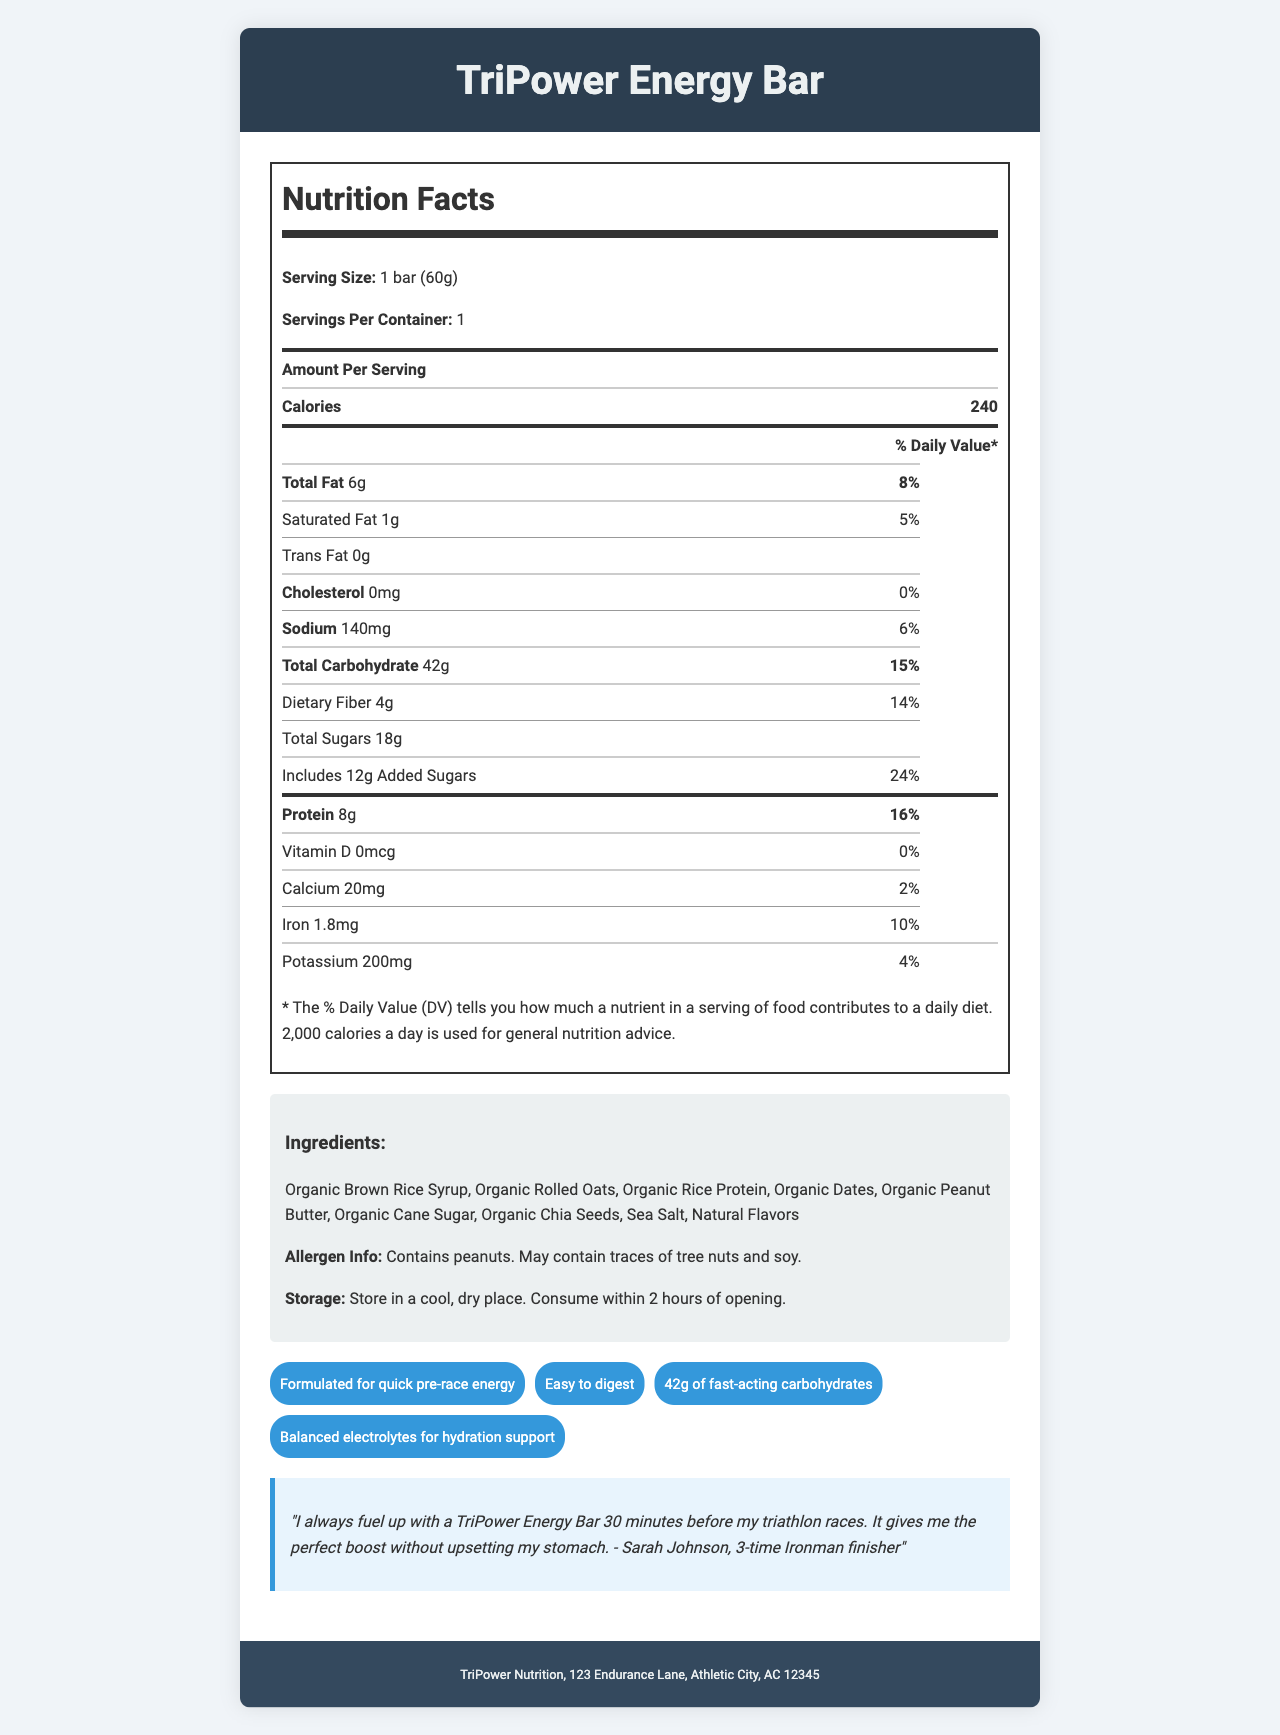what is the serving size of the TriPower Energy Bar? The document states that the serving size is 1 bar (60g).
Answer: 1 bar (60g) how many calories are there per serving? The document mentions that there are 240 calories per serving.
Answer: 240 what is the total carbohydrate content per serving? The document indicates that the total carbohydrate content per serving is 42g.
Answer: 42g how much dietary fiber does the TriPower Energy Bar have? The document lists the dietary fiber content as 4g per serving.
Answer: 4g what is the percentage of daily value for protein in this energy bar? The document specifies that the protein daily value percentage is 16%.
Answer: 16% which ingredient is listed first on the ingredients list? The first ingredient listed is Organic Brown Rice Syrup.
Answer: Organic Brown Rice Syrup how much added sugar does the TriPower Energy Bar contain? The document indicates that the energy bar contains 12g of added sugars.
Answer: 12g what company manufactures the TriPower Energy Bar? The manufacturer information in the document states that TriPower Nutrition produces the bar.
Answer: TriPower Nutrition does the TriPower Energy Bar contain any peanuts? The allergen info mentions that the product contains peanuts.
Answer: Yes which of the following is not listed as an ingredient? A. Organic Chia Seeds B. Organic Honey C. Organic Rolled Oats The document lists Organic Chia Seeds and Organic Rolled Oats, but not Organic Honey.
Answer: B. Organic Honey how much sodium is present in one serving of the energy bar? A. 120 mg B. 130 mg C. 140 mg D. 150 mg The nutrition facts indicate that each serving contains 140 mg of sodium.
Answer: C. 140 mg what is the daily value percentage for iron in the TriPower Energy Bar? A. 5% B. 10% C. 15% The nutrition facts show that the daily value percentage for iron is 10%.
Answer: B. 10% should the TriPower Energy Bar be stored in a cool, dry place? The storage instructions recommend keeping the bar in a cool, dry place.
Answer: Yes what is the main purpose of the TriPower Energy Bar according to the claim statements? The claim statements highlight that the bar is formulated for quick pre-race energy.
Answer: Quick pre-race energy which athlete endorses the TriPower Energy Bar in the testimonial? The document includes a testimonial from Sarah Johnson, a 3-time Ironman finisher.
Answer: Sarah Johnson what is the role of potassium in the TriPower Energy Bar? The document lists the amount of potassium and its daily value percentage but does not provide specific information about its role.
Answer: Not enough information 